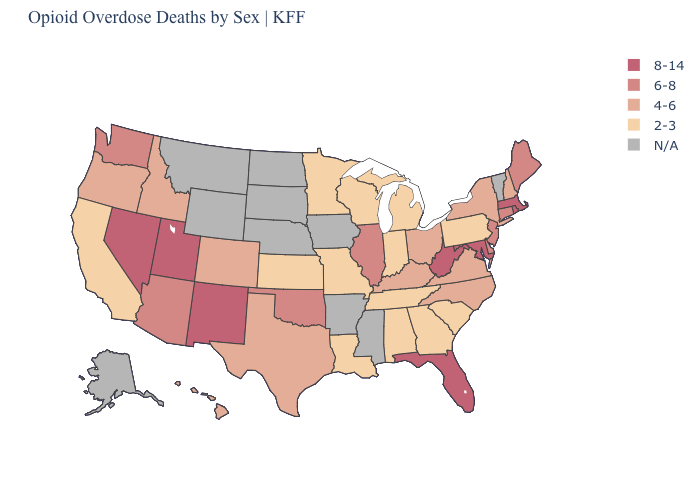Does the map have missing data?
Quick response, please. Yes. Which states have the highest value in the USA?
Concise answer only. Florida, Maryland, Massachusetts, Nevada, New Mexico, Rhode Island, Utah, West Virginia. Which states have the lowest value in the MidWest?
Short answer required. Indiana, Kansas, Michigan, Minnesota, Missouri, Wisconsin. Which states have the lowest value in the Northeast?
Short answer required. Pennsylvania. What is the value of Maine?
Give a very brief answer. 6-8. Name the states that have a value in the range 2-3?
Write a very short answer. Alabama, California, Georgia, Indiana, Kansas, Louisiana, Michigan, Minnesota, Missouri, Pennsylvania, South Carolina, Tennessee, Wisconsin. What is the lowest value in states that border Rhode Island?
Keep it brief. 6-8. Does Rhode Island have the lowest value in the Northeast?
Short answer required. No. Is the legend a continuous bar?
Give a very brief answer. No. What is the value of Kentucky?
Short answer required. 4-6. What is the value of Alaska?
Concise answer only. N/A. Name the states that have a value in the range 4-6?
Quick response, please. Colorado, Hawaii, Idaho, Kentucky, New Hampshire, New York, North Carolina, Ohio, Oregon, Texas, Virginia. What is the value of Wyoming?
Concise answer only. N/A. What is the value of Alabama?
Concise answer only. 2-3. What is the value of Rhode Island?
Short answer required. 8-14. 